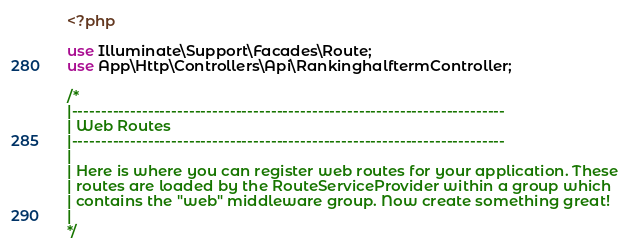Convert code to text. <code><loc_0><loc_0><loc_500><loc_500><_PHP_><?php

use Illuminate\Support\Facades\Route;
use App\Http\Controllers\Api\RankinghalftermController;

/*
|--------------------------------------------------------------------------
| Web Routes
|--------------------------------------------------------------------------
|
| Here is where you can register web routes for your application. These
| routes are loaded by the RouteServiceProvider within a group which
| contains the "web" middleware group. Now create something great!
|
*/
</code> 